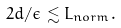<formula> <loc_0><loc_0><loc_500><loc_500>2 d / \epsilon \lesssim L _ { n o r m } .</formula> 